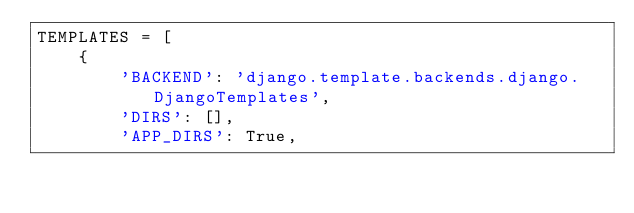Convert code to text. <code><loc_0><loc_0><loc_500><loc_500><_Python_>TEMPLATES = [
    {
        'BACKEND': 'django.template.backends.django.DjangoTemplates',
        'DIRS': [],
        'APP_DIRS': True,</code> 